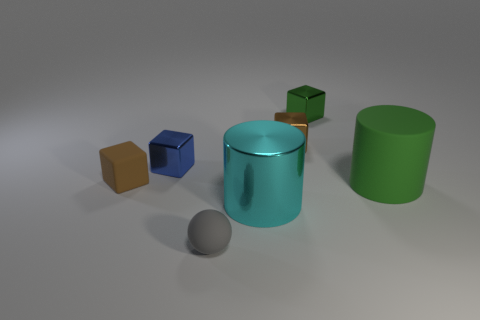Add 3 tiny blue metal things. How many objects exist? 10 Subtract all cylinders. How many objects are left? 5 Subtract 1 gray balls. How many objects are left? 6 Subtract all small green rubber blocks. Subtract all small metal blocks. How many objects are left? 4 Add 7 tiny gray matte balls. How many tiny gray matte balls are left? 8 Add 2 cyan matte balls. How many cyan matte balls exist? 2 